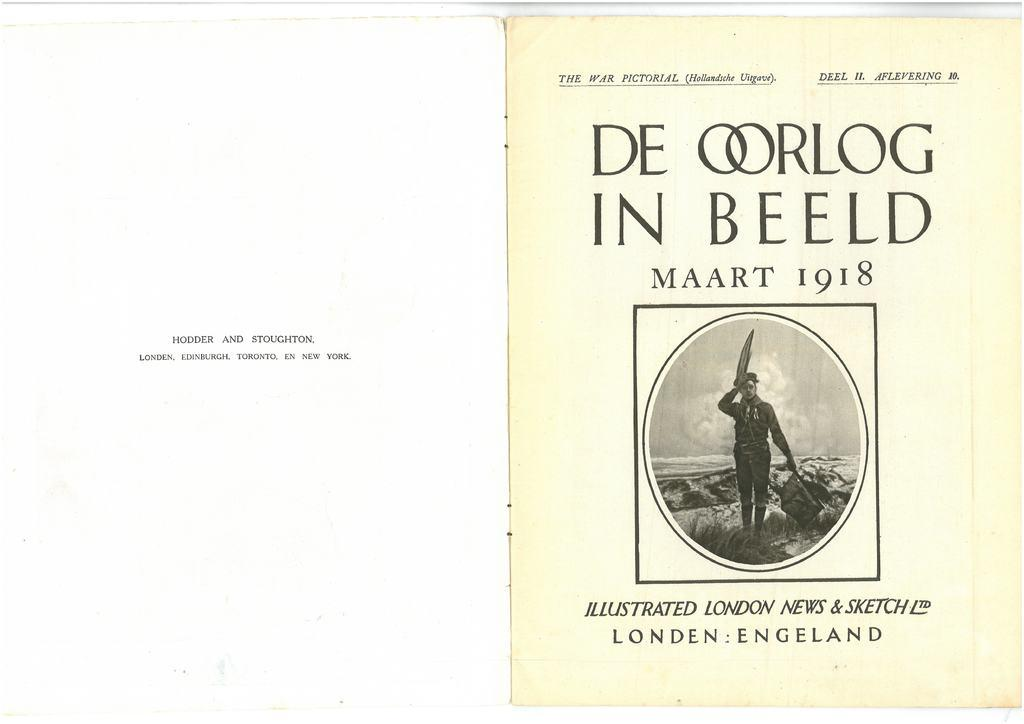<image>
Offer a succinct explanation of the picture presented. A book cover with the date 1918 has a person walking by the water on it. 